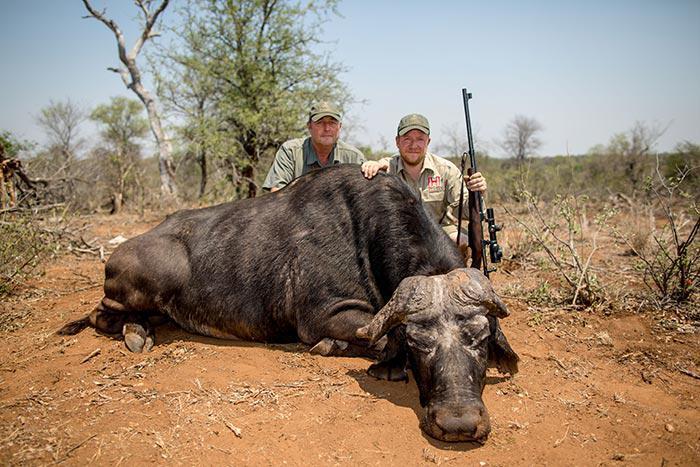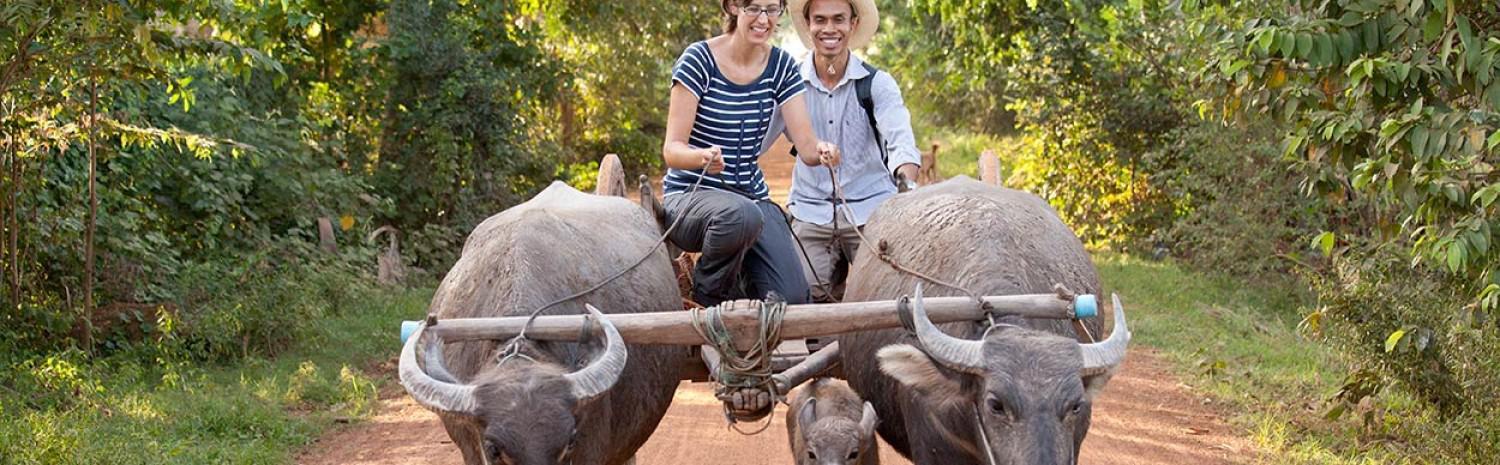The first image is the image on the left, the second image is the image on the right. Examine the images to the left and right. Is the description "Two hunters pose with a weapon behind a downed water buffalo in the left image." accurate? Answer yes or no. Yes. The first image is the image on the left, the second image is the image on the right. Evaluate the accuracy of this statement regarding the images: "In one of the images, two men can be seen posing next to a deceased water buffalo.". Is it true? Answer yes or no. Yes. 